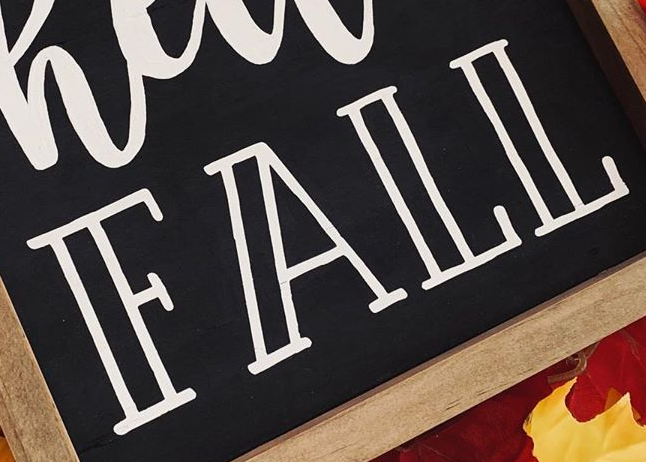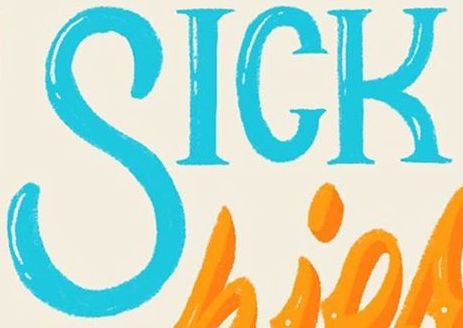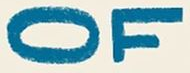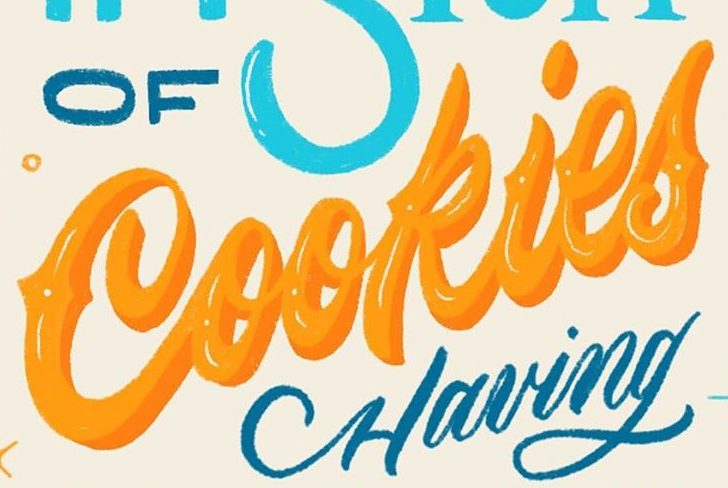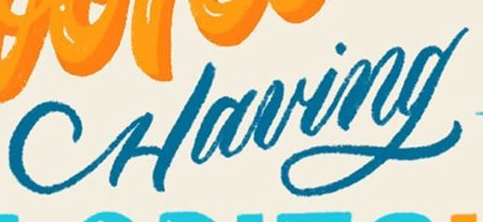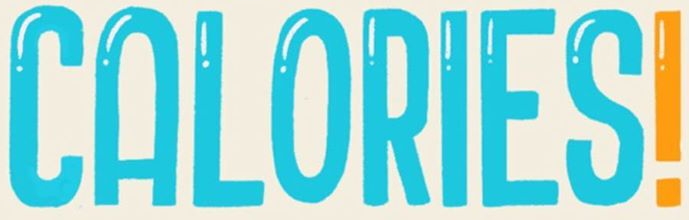Read the text from these images in sequence, separated by a semicolon. FALL; SICK; OF; Cookies; Having; CALORIES! 